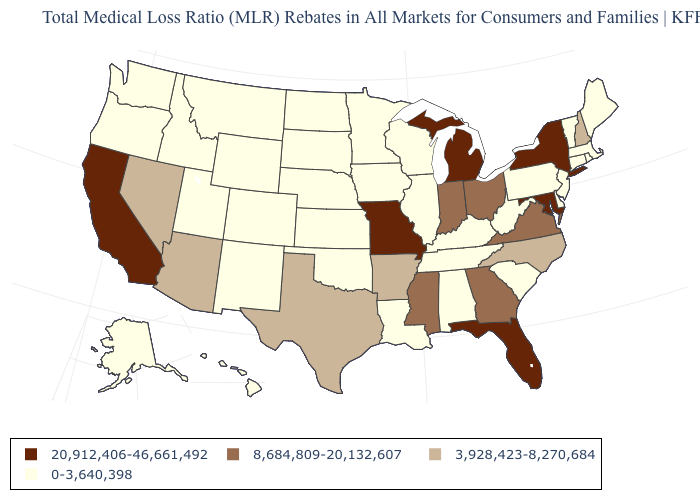Among the states that border New Jersey , which have the highest value?
Give a very brief answer. New York. What is the value of Missouri?
Concise answer only. 20,912,406-46,661,492. Among the states that border Maryland , which have the lowest value?
Concise answer only. Delaware, Pennsylvania, West Virginia. Does the map have missing data?
Write a very short answer. No. What is the value of South Carolina?
Write a very short answer. 0-3,640,398. Name the states that have a value in the range 20,912,406-46,661,492?
Quick response, please. California, Florida, Maryland, Michigan, Missouri, New York. Does Mississippi have a higher value than South Dakota?
Short answer required. Yes. What is the lowest value in the USA?
Be succinct. 0-3,640,398. What is the value of Washington?
Be succinct. 0-3,640,398. Does the map have missing data?
Quick response, please. No. What is the highest value in states that border Utah?
Quick response, please. 3,928,423-8,270,684. Name the states that have a value in the range 8,684,809-20,132,607?
Short answer required. Georgia, Indiana, Mississippi, Ohio, Virginia. Does the map have missing data?
Keep it brief. No. Which states have the lowest value in the USA?
Write a very short answer. Alabama, Alaska, Colorado, Connecticut, Delaware, Hawaii, Idaho, Illinois, Iowa, Kansas, Kentucky, Louisiana, Maine, Massachusetts, Minnesota, Montana, Nebraska, New Jersey, New Mexico, North Dakota, Oklahoma, Oregon, Pennsylvania, Rhode Island, South Carolina, South Dakota, Tennessee, Utah, Vermont, Washington, West Virginia, Wisconsin, Wyoming. 